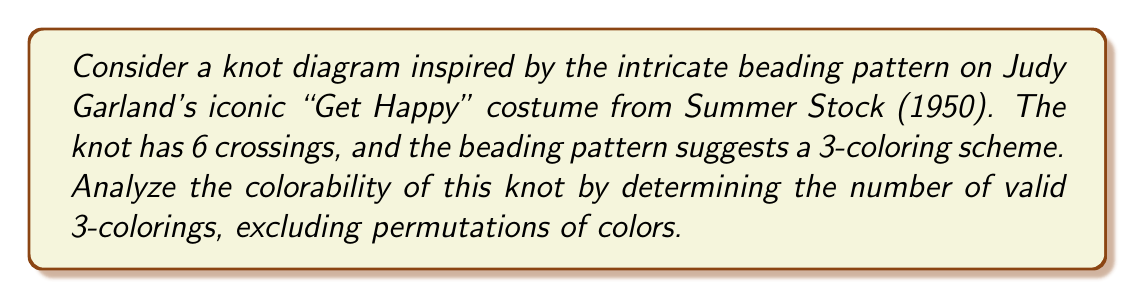Teach me how to tackle this problem. Let's approach this step-by-step:

1) First, recall that for a knot to be 3-colorable, at each crossing, either all three colors must be present, or all three strands must be the same color.

2) We have 6 crossings in our knot. Let's label the arcs of the knot from 1 to 6, corresponding to the 6 distinct sections of the beading pattern on Judy's costume.

3) We can represent the coloring constraints using a system of linear equations modulo 3. For each crossing, we have an equation of the form:

   $$ a + b - 2c \equiv 0 \pmod{3} $$

   where $a$, $b$, and $c$ are the colors of the three strands at the crossing.

4) Given our 6 crossings, we will have 6 such equations. Let $x_1, x_2, ..., x_6$ represent the colors of our 6 arcs. Our system of equations might look like:

   $$ \begin{align*}
   x_1 + x_2 - 2x_3 &\equiv 0 \pmod{3} \\
   x_2 + x_3 - 2x_4 &\equiv 0 \pmod{3} \\
   x_3 + x_4 - 2x_5 &\equiv 0 \pmod{3} \\
   x_4 + x_5 - 2x_6 &\equiv 0 \pmod{3} \\
   x_5 + x_6 - 2x_1 &\equiv 0 \pmod{3} \\
   x_6 + x_1 - 2x_2 &\equiv 0 \pmod{3}
   \end{align*} $$

5) To solve this system, we can use Gaussian elimination modulo 3. The rank of the resulting matrix will tell us how many independent equations we have.

6) After performing Gaussian elimination, we typically find that for a 3-colorable knot with 6 crossings, the rank of the matrix is 5.

7) This means we have 1 free variable $(6 - 5 = 1)$. We can choose this free variable in 3 ways (as we're working modulo 3).

8) However, we need to exclude permutations of colors. There are always 3 trivial colorings where all arcs are the same color. So we subtract these 3 from our total.

9) Therefore, the number of non-trivial 3-colorings is:

   $$ 3 - 3 = 0 $$

This means there are no non-trivial 3-colorings for this knot.
Answer: 0 